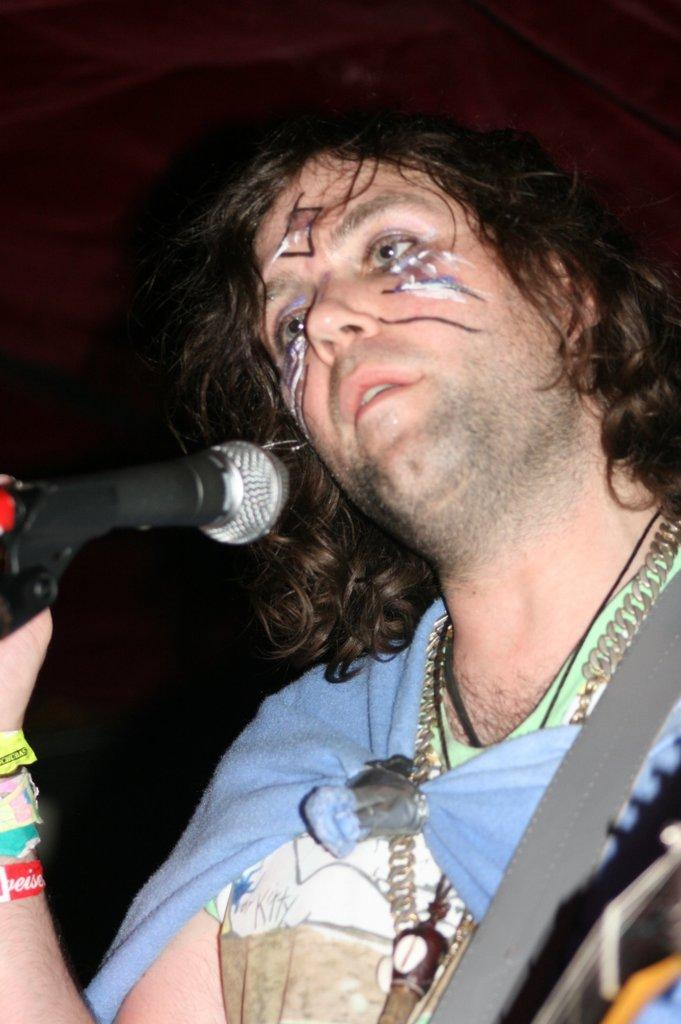Who is present in the image? There is a man in the image. What is the man holding in the image? The man is holding a microphone. What color is the wall in the background of the image? There is a red wall in the background of the image. What furniture can be seen in the background of the image? There is a chair in the background of the image. What type of cushion is used for the flight in the image? There is no flight or cushion present in the image; it features a man holding a microphone with a red wall and a chair in the background. 